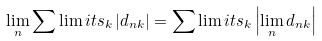<formula> <loc_0><loc_0><loc_500><loc_500>\lim _ { n } \sum \lim i t s _ { k } \left | d _ { n k } \right | = \sum \lim i t s _ { k } \left | \lim _ { n } d _ { n k } \right |</formula> 